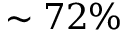<formula> <loc_0><loc_0><loc_500><loc_500>\sim 7 2 \%</formula> 